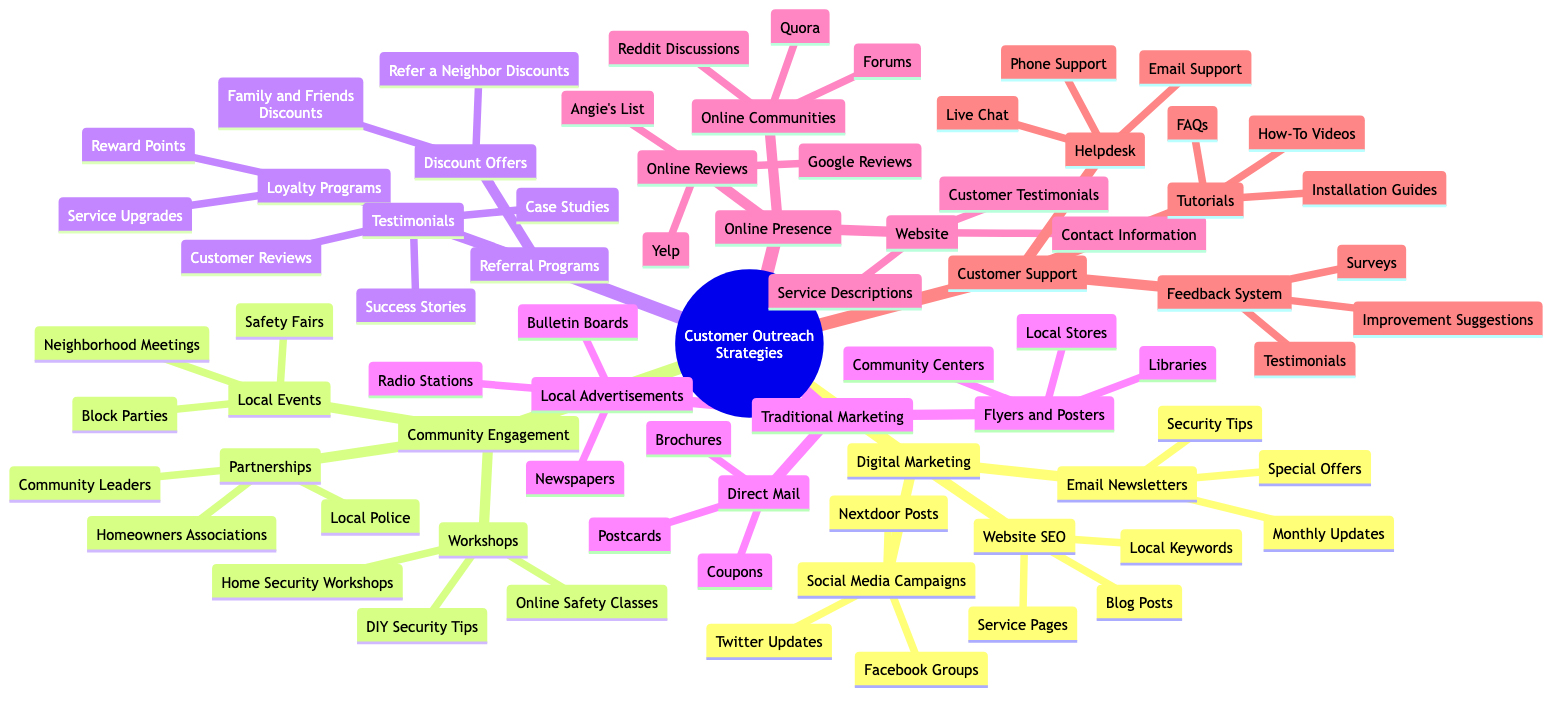What is the primary category for marketing strategies in the diagram? The diagram has "Customer Outreach Strategies for Neighborhood Safety Services" as the root, from which branches represent several primary categories. One of these primary categories is "Digital Marketing".
Answer: Digital Marketing How many specific strategies are listed under "Community Engagement"? Under the "Community Engagement" branch, there are three specific strategies: "Local Events", "Workshops", and "Partnerships", making a total of three.
Answer: 3 Which social media platform is mentioned for campaigns? The "Social Media Campaigns" category under "Digital Marketing" lists "Facebook Groups", along with other platforms, indicating that Facebook is one of the mentioned platforms.
Answer: Facebook Groups What type of program offers "Refer a Neighbor Discounts"? The "Discount Offers" category under "Referral Programs" directly states "Refer a Neighbor Discounts" as one of the types of offers available in this program.
Answer: Discount Offers In which category would you find "Helpdesk" support? "Helpdesk" is categorized under "Customer Support", making it clear that this type of support focuses on customer assistance.
Answer: Customer Support Which traditional marketing method involves using printed materials? "Flyers and Posters" is a method listed under "Traditional Marketing" that involves using printed materials to reach customers.
Answer: Flyers and Posters What is one type of tutorial provided in the customer support section? The diagram includes "How-To Videos" as one of the tutorials listed under the "Tutorials" category within "Customer Support".
Answer: How-To Videos How many platforms are included under "Online Reviews"? The "Online Reviews" category contains three specific platforms: "Google Reviews", "Yelp", and "Angie's List", giving a total of three platforms.
Answer: 3 What type of events are categorized under "Local Events"? "Neighborhood Meetings", "Block Parties", and "Safety Fairs" are listed under the "Local Events" category, indicating that these types of events focus on engagement within the community.
Answer: Local Events 